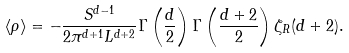Convert formula to latex. <formula><loc_0><loc_0><loc_500><loc_500>\langle \rho \rangle = - \frac { S ^ { d - 1 } } { 2 \pi ^ { d + 1 } L ^ { d + 2 } } \Gamma \left ( \frac { d } { 2 } \right ) \Gamma \left ( \frac { d + 2 } { 2 } \right ) \zeta _ { R } ( d + 2 ) .</formula> 